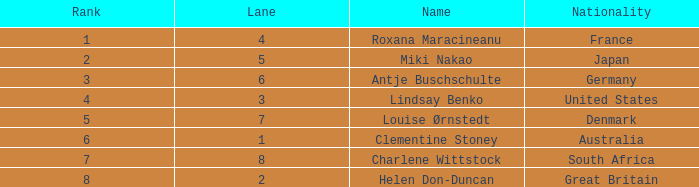What is the number of lane with a rank more than 2 for louise ørnstedt? 1.0. 